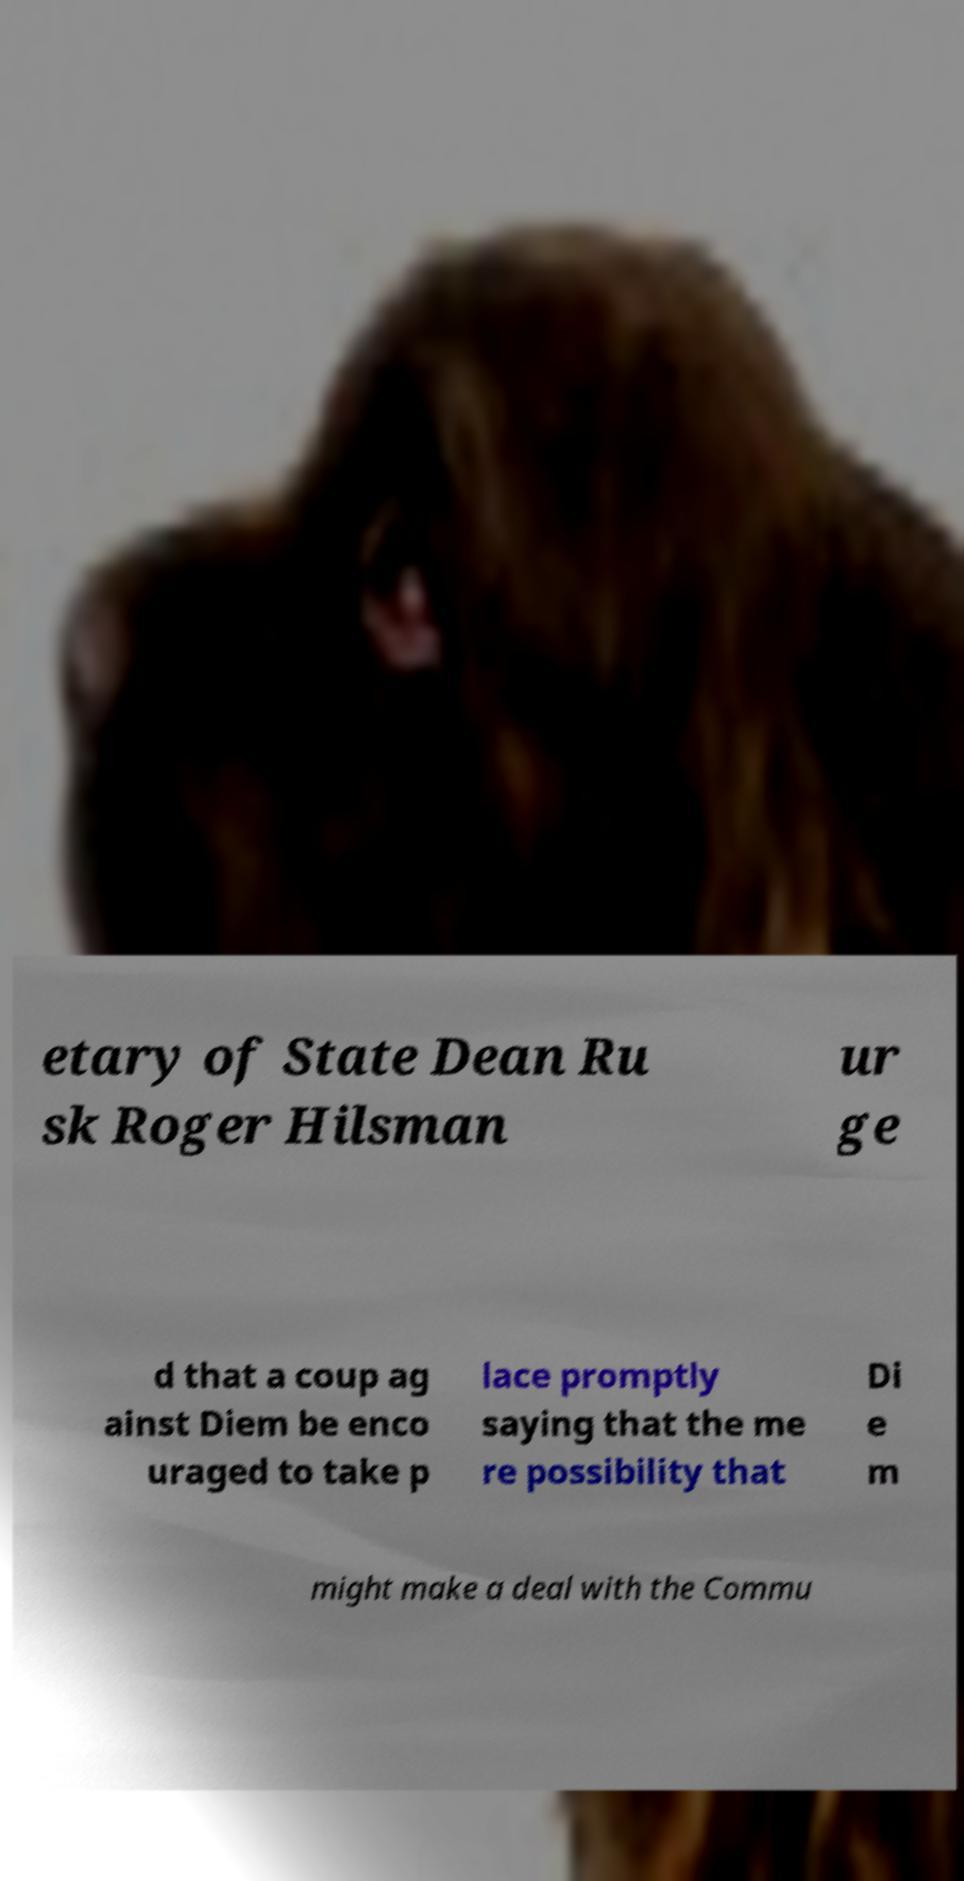Can you read and provide the text displayed in the image?This photo seems to have some interesting text. Can you extract and type it out for me? etary of State Dean Ru sk Roger Hilsman ur ge d that a coup ag ainst Diem be enco uraged to take p lace promptly saying that the me re possibility that Di e m might make a deal with the Commu 